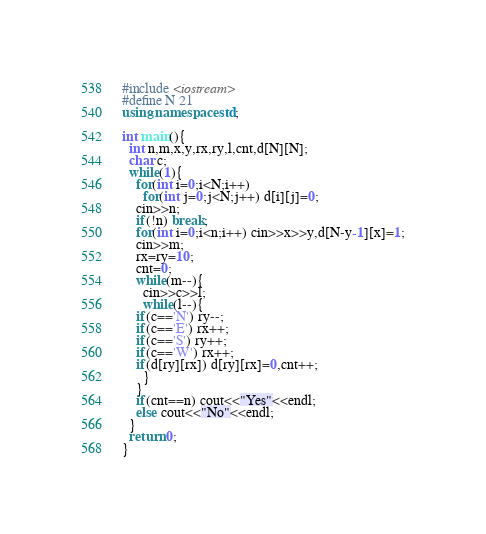<code> <loc_0><loc_0><loc_500><loc_500><_C++_>#include <iostream>
#define N 21
using namespace std;

int main(){
  int n,m,x,y,rx,ry,l,cnt,d[N][N];
  char c;
  while(1){
    for(int i=0;i<N;i++)
      for(int j=0;j<N;j++) d[i][j]=0;
    cin>>n;
    if(!n) break;
    for(int i=0;i<n;i++) cin>>x>>y,d[N-y-1][x]=1;
    cin>>m;
    rx=ry=10;
    cnt=0;
    while(m--){
      cin>>c>>l;
      while(l--){
	if(c=='N') ry--;
	if(c=='E') rx++;
	if(c=='S') ry++;
	if(c=='W') rx++;
	if(d[ry][rx]) d[ry][rx]=0,cnt++;
      }
    }
    if(cnt==n) cout<<"Yes"<<endl;
    else cout<<"No"<<endl;
  }
  return 0;
}</code> 